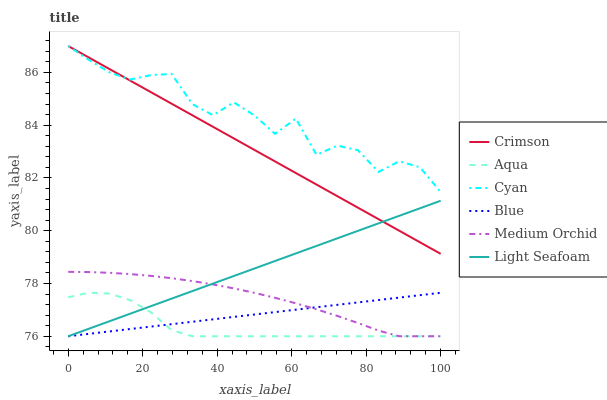Does Aqua have the minimum area under the curve?
Answer yes or no. Yes. Does Cyan have the maximum area under the curve?
Answer yes or no. Yes. Does Medium Orchid have the minimum area under the curve?
Answer yes or no. No. Does Medium Orchid have the maximum area under the curve?
Answer yes or no. No. Is Crimson the smoothest?
Answer yes or no. Yes. Is Cyan the roughest?
Answer yes or no. Yes. Is Medium Orchid the smoothest?
Answer yes or no. No. Is Medium Orchid the roughest?
Answer yes or no. No. Does Blue have the lowest value?
Answer yes or no. Yes. Does Crimson have the lowest value?
Answer yes or no. No. Does Cyan have the highest value?
Answer yes or no. Yes. Does Medium Orchid have the highest value?
Answer yes or no. No. Is Medium Orchid less than Crimson?
Answer yes or no. Yes. Is Cyan greater than Blue?
Answer yes or no. Yes. Does Aqua intersect Blue?
Answer yes or no. Yes. Is Aqua less than Blue?
Answer yes or no. No. Is Aqua greater than Blue?
Answer yes or no. No. Does Medium Orchid intersect Crimson?
Answer yes or no. No. 